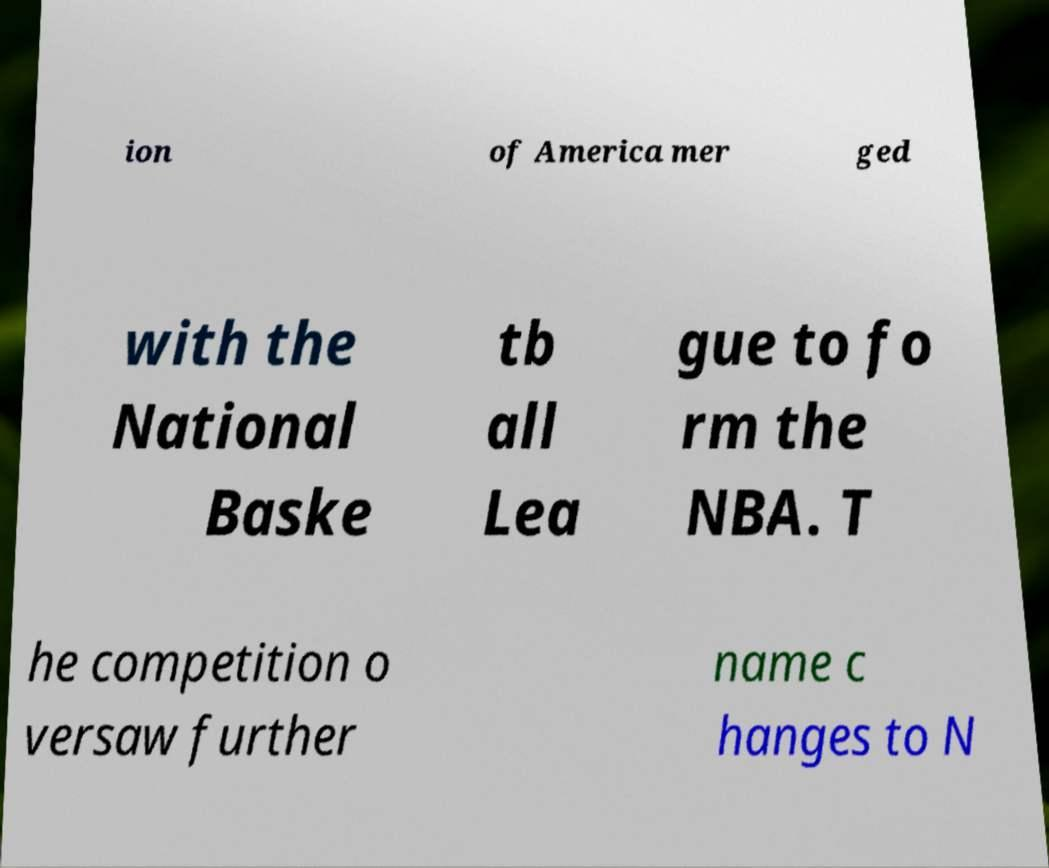Could you assist in decoding the text presented in this image and type it out clearly? ion of America mer ged with the National Baske tb all Lea gue to fo rm the NBA. T he competition o versaw further name c hanges to N 